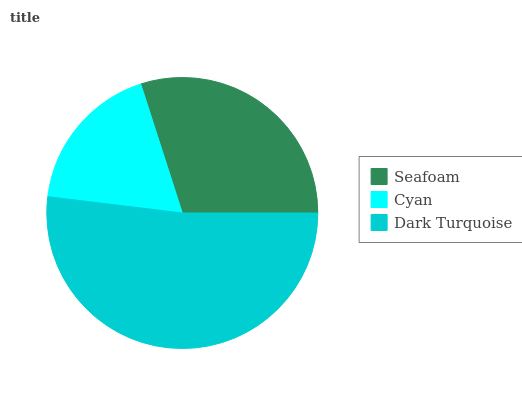Is Cyan the minimum?
Answer yes or no. Yes. Is Dark Turquoise the maximum?
Answer yes or no. Yes. Is Dark Turquoise the minimum?
Answer yes or no. No. Is Cyan the maximum?
Answer yes or no. No. Is Dark Turquoise greater than Cyan?
Answer yes or no. Yes. Is Cyan less than Dark Turquoise?
Answer yes or no. Yes. Is Cyan greater than Dark Turquoise?
Answer yes or no. No. Is Dark Turquoise less than Cyan?
Answer yes or no. No. Is Seafoam the high median?
Answer yes or no. Yes. Is Seafoam the low median?
Answer yes or no. Yes. Is Dark Turquoise the high median?
Answer yes or no. No. Is Cyan the low median?
Answer yes or no. No. 